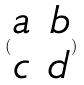<formula> <loc_0><loc_0><loc_500><loc_500>( \begin{matrix} a & b \\ c & d \end{matrix} )</formula> 